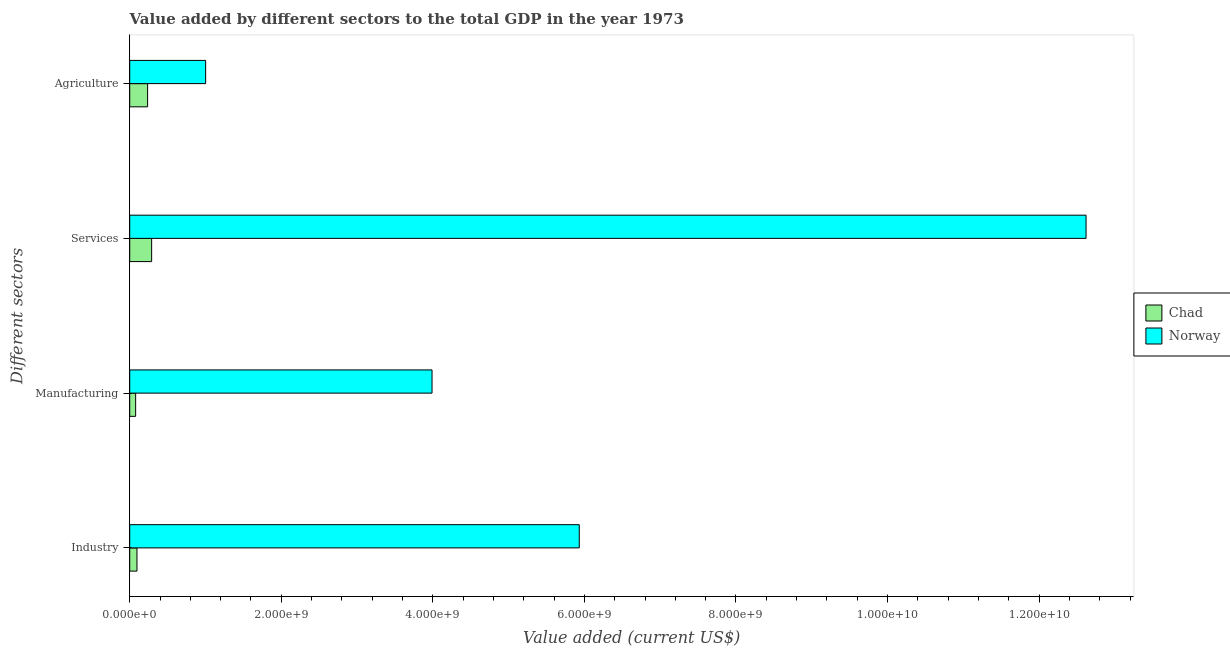Are the number of bars per tick equal to the number of legend labels?
Your answer should be compact. Yes. Are the number of bars on each tick of the Y-axis equal?
Provide a succinct answer. Yes. What is the label of the 2nd group of bars from the top?
Offer a terse response. Services. What is the value added by agricultural sector in Chad?
Give a very brief answer. 2.36e+08. Across all countries, what is the maximum value added by manufacturing sector?
Your answer should be very brief. 3.99e+09. Across all countries, what is the minimum value added by agricultural sector?
Make the answer very short. 2.36e+08. In which country was the value added by industrial sector minimum?
Provide a succinct answer. Chad. What is the total value added by services sector in the graph?
Ensure brevity in your answer.  1.29e+1. What is the difference between the value added by agricultural sector in Norway and that in Chad?
Offer a very short reply. 7.66e+08. What is the difference between the value added by services sector in Chad and the value added by industrial sector in Norway?
Your answer should be very brief. -5.64e+09. What is the average value added by manufacturing sector per country?
Ensure brevity in your answer.  2.03e+09. What is the difference between the value added by industrial sector and value added by manufacturing sector in Chad?
Provide a succinct answer. 1.75e+07. In how many countries, is the value added by services sector greater than 8800000000 US$?
Your answer should be very brief. 1. What is the ratio of the value added by manufacturing sector in Chad to that in Norway?
Keep it short and to the point. 0.02. Is the difference between the value added by agricultural sector in Norway and Chad greater than the difference between the value added by industrial sector in Norway and Chad?
Keep it short and to the point. No. What is the difference between the highest and the second highest value added by manufacturing sector?
Make the answer very short. 3.91e+09. What is the difference between the highest and the lowest value added by manufacturing sector?
Keep it short and to the point. 3.91e+09. Is the sum of the value added by manufacturing sector in Norway and Chad greater than the maximum value added by agricultural sector across all countries?
Your response must be concise. Yes. Is it the case that in every country, the sum of the value added by manufacturing sector and value added by agricultural sector is greater than the sum of value added by industrial sector and value added by services sector?
Your answer should be very brief. No. What does the 1st bar from the top in Manufacturing represents?
Offer a very short reply. Norway. What does the 1st bar from the bottom in Manufacturing represents?
Your answer should be very brief. Chad. Is it the case that in every country, the sum of the value added by industrial sector and value added by manufacturing sector is greater than the value added by services sector?
Offer a very short reply. No. What is the difference between two consecutive major ticks on the X-axis?
Your response must be concise. 2.00e+09. Are the values on the major ticks of X-axis written in scientific E-notation?
Keep it short and to the point. Yes. Does the graph contain any zero values?
Make the answer very short. No. Does the graph contain grids?
Keep it short and to the point. No. What is the title of the graph?
Your response must be concise. Value added by different sectors to the total GDP in the year 1973. Does "Luxembourg" appear as one of the legend labels in the graph?
Your response must be concise. No. What is the label or title of the X-axis?
Offer a very short reply. Value added (current US$). What is the label or title of the Y-axis?
Provide a succinct answer. Different sectors. What is the Value added (current US$) of Chad in Industry?
Your answer should be compact. 9.56e+07. What is the Value added (current US$) in Norway in Industry?
Provide a short and direct response. 5.93e+09. What is the Value added (current US$) in Chad in Manufacturing?
Provide a succinct answer. 7.81e+07. What is the Value added (current US$) of Norway in Manufacturing?
Make the answer very short. 3.99e+09. What is the Value added (current US$) of Chad in Services?
Your response must be concise. 2.89e+08. What is the Value added (current US$) in Norway in Services?
Provide a succinct answer. 1.26e+1. What is the Value added (current US$) of Chad in Agriculture?
Keep it short and to the point. 2.36e+08. What is the Value added (current US$) of Norway in Agriculture?
Ensure brevity in your answer.  1.00e+09. Across all Different sectors, what is the maximum Value added (current US$) in Chad?
Give a very brief answer. 2.89e+08. Across all Different sectors, what is the maximum Value added (current US$) in Norway?
Your answer should be very brief. 1.26e+1. Across all Different sectors, what is the minimum Value added (current US$) of Chad?
Offer a terse response. 7.81e+07. Across all Different sectors, what is the minimum Value added (current US$) of Norway?
Ensure brevity in your answer.  1.00e+09. What is the total Value added (current US$) of Chad in the graph?
Provide a short and direct response. 6.99e+08. What is the total Value added (current US$) of Norway in the graph?
Ensure brevity in your answer.  2.35e+1. What is the difference between the Value added (current US$) of Chad in Industry and that in Manufacturing?
Your response must be concise. 1.75e+07. What is the difference between the Value added (current US$) in Norway in Industry and that in Manufacturing?
Keep it short and to the point. 1.94e+09. What is the difference between the Value added (current US$) in Chad in Industry and that in Services?
Make the answer very short. -1.94e+08. What is the difference between the Value added (current US$) in Norway in Industry and that in Services?
Give a very brief answer. -6.69e+09. What is the difference between the Value added (current US$) of Chad in Industry and that in Agriculture?
Make the answer very short. -1.40e+08. What is the difference between the Value added (current US$) of Norway in Industry and that in Agriculture?
Give a very brief answer. 4.93e+09. What is the difference between the Value added (current US$) in Chad in Manufacturing and that in Services?
Your answer should be very brief. -2.11e+08. What is the difference between the Value added (current US$) of Norway in Manufacturing and that in Services?
Keep it short and to the point. -8.63e+09. What is the difference between the Value added (current US$) of Chad in Manufacturing and that in Agriculture?
Provide a short and direct response. -1.58e+08. What is the difference between the Value added (current US$) of Norway in Manufacturing and that in Agriculture?
Provide a short and direct response. 2.99e+09. What is the difference between the Value added (current US$) of Chad in Services and that in Agriculture?
Offer a terse response. 5.31e+07. What is the difference between the Value added (current US$) of Norway in Services and that in Agriculture?
Provide a short and direct response. 1.16e+1. What is the difference between the Value added (current US$) in Chad in Industry and the Value added (current US$) in Norway in Manufacturing?
Provide a short and direct response. -3.89e+09. What is the difference between the Value added (current US$) in Chad in Industry and the Value added (current US$) in Norway in Services?
Provide a succinct answer. -1.25e+1. What is the difference between the Value added (current US$) in Chad in Industry and the Value added (current US$) in Norway in Agriculture?
Your answer should be very brief. -9.06e+08. What is the difference between the Value added (current US$) of Chad in Manufacturing and the Value added (current US$) of Norway in Services?
Give a very brief answer. -1.25e+1. What is the difference between the Value added (current US$) of Chad in Manufacturing and the Value added (current US$) of Norway in Agriculture?
Provide a succinct answer. -9.24e+08. What is the difference between the Value added (current US$) of Chad in Services and the Value added (current US$) of Norway in Agriculture?
Provide a succinct answer. -7.13e+08. What is the average Value added (current US$) in Chad per Different sectors?
Keep it short and to the point. 1.75e+08. What is the average Value added (current US$) of Norway per Different sectors?
Provide a succinct answer. 5.89e+09. What is the difference between the Value added (current US$) in Chad and Value added (current US$) in Norway in Industry?
Provide a succinct answer. -5.84e+09. What is the difference between the Value added (current US$) of Chad and Value added (current US$) of Norway in Manufacturing?
Give a very brief answer. -3.91e+09. What is the difference between the Value added (current US$) in Chad and Value added (current US$) in Norway in Services?
Provide a succinct answer. -1.23e+1. What is the difference between the Value added (current US$) in Chad and Value added (current US$) in Norway in Agriculture?
Your response must be concise. -7.66e+08. What is the ratio of the Value added (current US$) of Chad in Industry to that in Manufacturing?
Make the answer very short. 1.22. What is the ratio of the Value added (current US$) in Norway in Industry to that in Manufacturing?
Make the answer very short. 1.49. What is the ratio of the Value added (current US$) in Chad in Industry to that in Services?
Give a very brief answer. 0.33. What is the ratio of the Value added (current US$) of Norway in Industry to that in Services?
Ensure brevity in your answer.  0.47. What is the ratio of the Value added (current US$) of Chad in Industry to that in Agriculture?
Your response must be concise. 0.41. What is the ratio of the Value added (current US$) in Norway in Industry to that in Agriculture?
Your answer should be very brief. 5.92. What is the ratio of the Value added (current US$) of Chad in Manufacturing to that in Services?
Offer a very short reply. 0.27. What is the ratio of the Value added (current US$) of Norway in Manufacturing to that in Services?
Provide a succinct answer. 0.32. What is the ratio of the Value added (current US$) of Chad in Manufacturing to that in Agriculture?
Ensure brevity in your answer.  0.33. What is the ratio of the Value added (current US$) of Norway in Manufacturing to that in Agriculture?
Provide a succinct answer. 3.98. What is the ratio of the Value added (current US$) in Chad in Services to that in Agriculture?
Offer a very short reply. 1.23. What is the ratio of the Value added (current US$) of Norway in Services to that in Agriculture?
Keep it short and to the point. 12.6. What is the difference between the highest and the second highest Value added (current US$) in Chad?
Provide a short and direct response. 5.31e+07. What is the difference between the highest and the second highest Value added (current US$) of Norway?
Offer a very short reply. 6.69e+09. What is the difference between the highest and the lowest Value added (current US$) in Chad?
Your answer should be compact. 2.11e+08. What is the difference between the highest and the lowest Value added (current US$) in Norway?
Provide a short and direct response. 1.16e+1. 